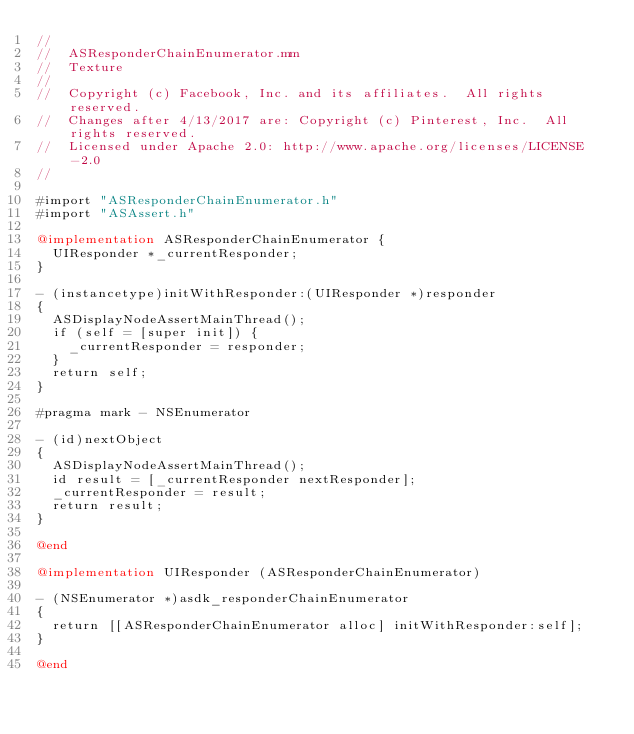<code> <loc_0><loc_0><loc_500><loc_500><_ObjectiveC_>//
//  ASResponderChainEnumerator.mm
//  Texture
//
//  Copyright (c) Facebook, Inc. and its affiliates.  All rights reserved.
//  Changes after 4/13/2017 are: Copyright (c) Pinterest, Inc.  All rights reserved.
//  Licensed under Apache 2.0: http://www.apache.org/licenses/LICENSE-2.0
//

#import "ASResponderChainEnumerator.h"
#import "ASAssert.h"

@implementation ASResponderChainEnumerator {
  UIResponder *_currentResponder;
}

- (instancetype)initWithResponder:(UIResponder *)responder
{
  ASDisplayNodeAssertMainThread();
  if (self = [super init]) {
    _currentResponder = responder;
  }
  return self;
}

#pragma mark - NSEnumerator

- (id)nextObject
{
  ASDisplayNodeAssertMainThread();
  id result = [_currentResponder nextResponder];
  _currentResponder = result;
  return result;
}

@end

@implementation UIResponder (ASResponderChainEnumerator)

- (NSEnumerator *)asdk_responderChainEnumerator
{
  return [[ASResponderChainEnumerator alloc] initWithResponder:self];
}

@end
</code> 